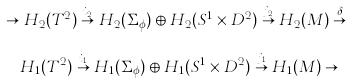<formula> <loc_0><loc_0><loc_500><loc_500>\cdots \to H _ { 2 } ( T ^ { 2 } ) \overset { i _ { 2 } } { \to } H _ { 2 } ( \Sigma _ { \phi } ) \oplus H _ { 2 } ( S ^ { 1 } \times D ^ { 2 } ) \overset { j _ { 2 } } \to H _ { 2 } ( M ) \overset { \delta } { \to } \\ H _ { 1 } ( T ^ { 2 } ) \overset { i _ { 1 } } \to H _ { 1 } ( \Sigma _ { \phi } ) \oplus H _ { 1 } ( S ^ { 1 } \times D ^ { 2 } ) \overset { j _ { 1 } } { \to } H _ { 1 } ( M ) \to \cdots</formula> 